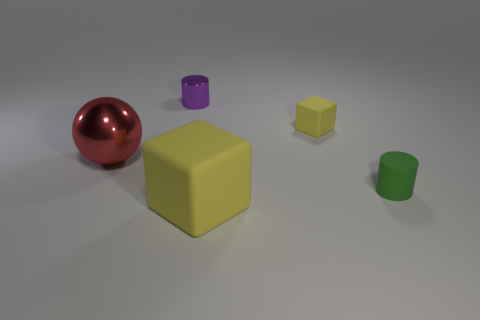There is a big yellow rubber thing; is it the same shape as the tiny matte object that is in front of the big red thing?
Provide a succinct answer. No. There is a yellow thing that is in front of the green cylinder; does it have the same size as the thing on the left side of the tiny purple metallic object?
Your answer should be compact. Yes. How many other things are there of the same shape as the large metallic object?
Your answer should be very brief. 0. There is a cylinder that is in front of the cylinder that is behind the large metal object; what is its material?
Give a very brief answer. Rubber. How many rubber things are spheres or purple objects?
Offer a very short reply. 0. There is a cylinder behind the red metal object; is there a red object that is behind it?
Give a very brief answer. No. How many objects are yellow matte cubes behind the small green rubber thing or matte objects behind the rubber cylinder?
Make the answer very short. 1. Is there any other thing that is the same color as the shiny cylinder?
Your answer should be very brief. No. What is the color of the small metallic cylinder that is to the left of the tiny cylinder that is on the right side of the large object to the right of the small purple object?
Your answer should be compact. Purple. There is a shiny object that is on the left side of the tiny cylinder that is behind the small green thing; what is its size?
Your answer should be very brief. Large. 